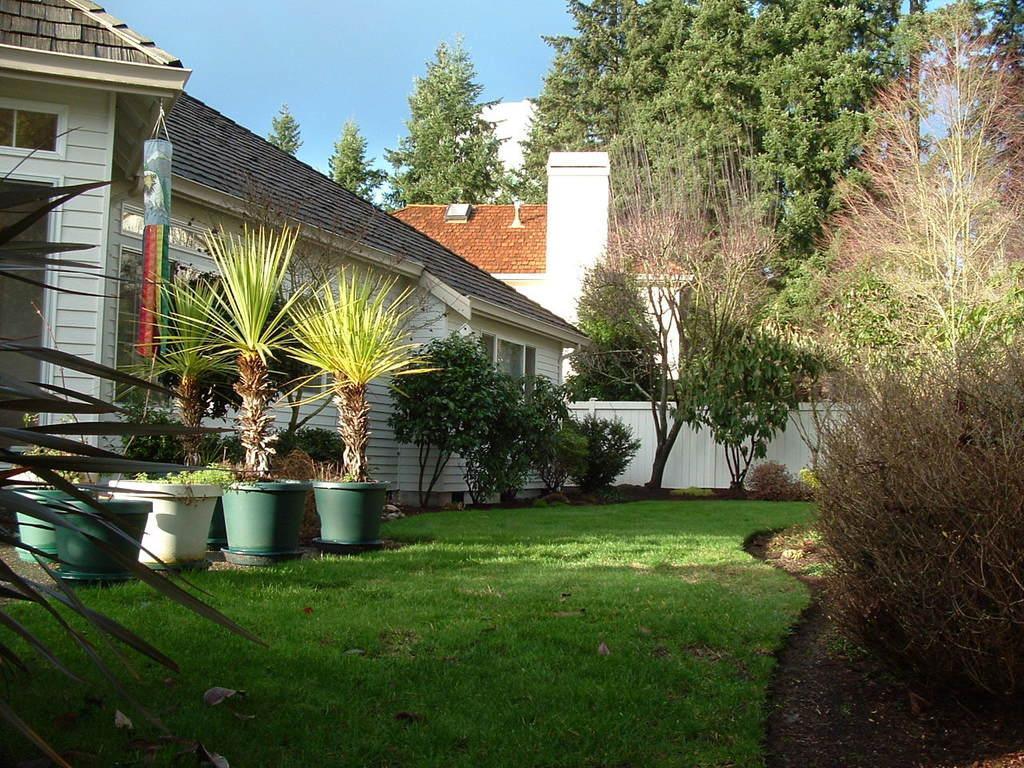Can you describe this image briefly? This is a garden. Here I can see many plants, trees and grass on the ground. In the background there are some houses. At the top of the image I can see the sky. 